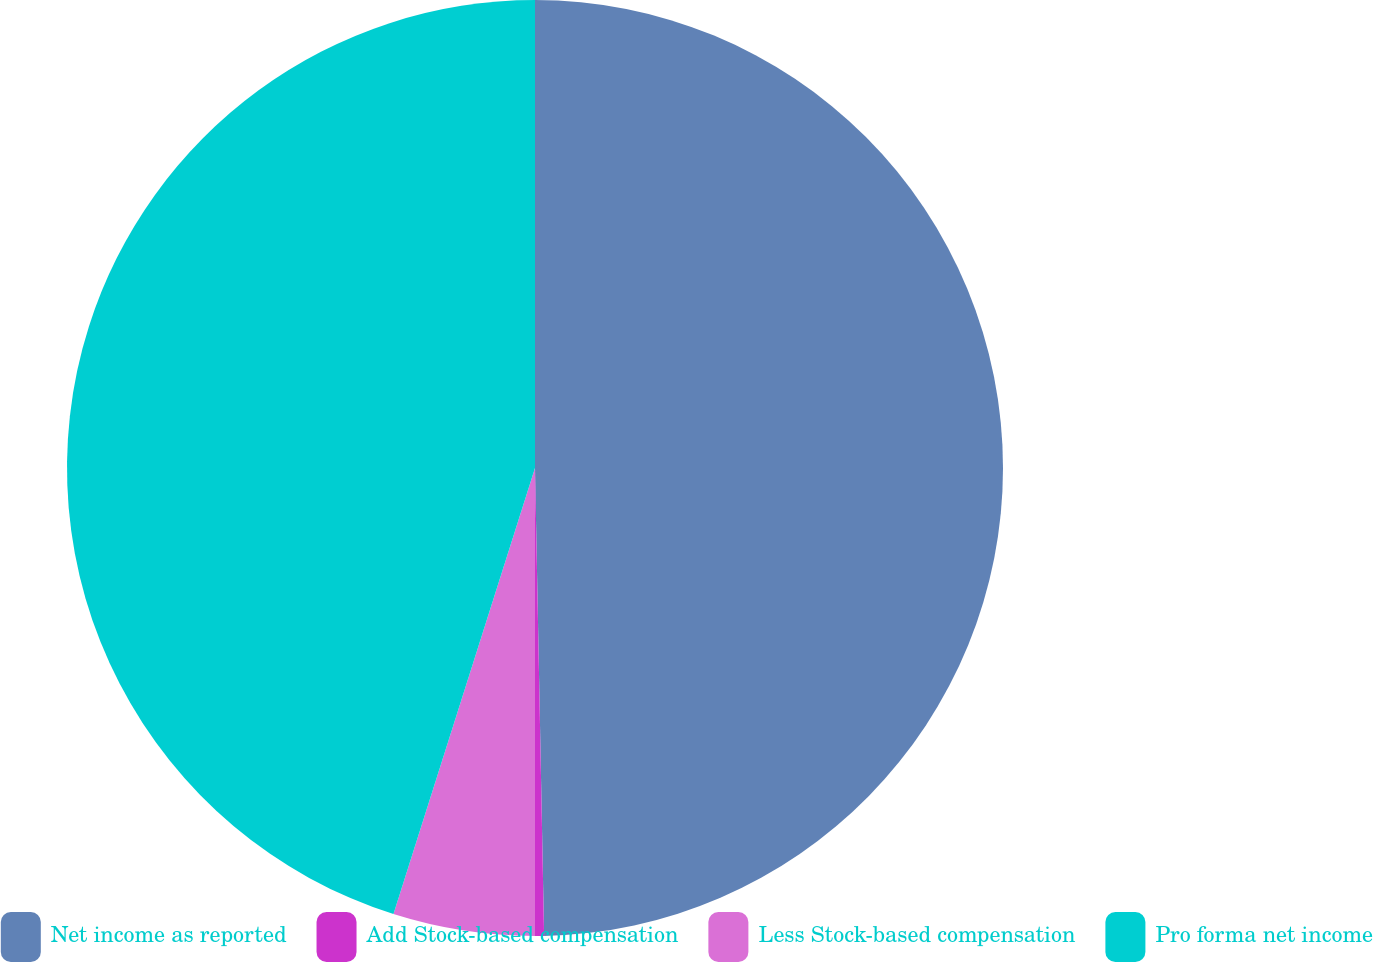<chart> <loc_0><loc_0><loc_500><loc_500><pie_chart><fcel>Net income as reported<fcel>Add Stock-based compensation<fcel>Less Stock-based compensation<fcel>Pro forma net income<nl><fcel>49.69%<fcel>0.31%<fcel>4.89%<fcel>45.11%<nl></chart> 